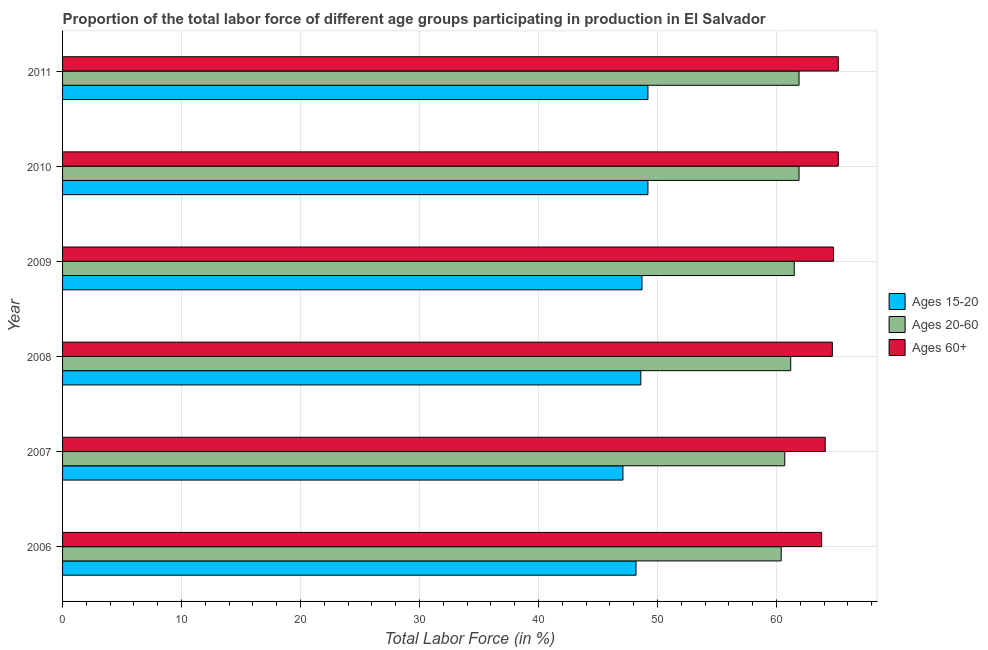How many different coloured bars are there?
Give a very brief answer. 3. How many bars are there on the 6th tick from the top?
Provide a short and direct response. 3. How many bars are there on the 5th tick from the bottom?
Your answer should be very brief. 3. What is the label of the 6th group of bars from the top?
Provide a succinct answer. 2006. What is the percentage of labor force within the age group 20-60 in 2011?
Your response must be concise. 61.9. Across all years, what is the maximum percentage of labor force above age 60?
Keep it short and to the point. 65.2. Across all years, what is the minimum percentage of labor force within the age group 15-20?
Offer a terse response. 47.1. What is the total percentage of labor force within the age group 20-60 in the graph?
Give a very brief answer. 367.6. What is the difference between the percentage of labor force within the age group 15-20 in 2009 and that in 2011?
Make the answer very short. -0.5. What is the difference between the percentage of labor force above age 60 in 2009 and the percentage of labor force within the age group 20-60 in 2011?
Provide a succinct answer. 2.9. What is the average percentage of labor force within the age group 20-60 per year?
Offer a terse response. 61.27. In the year 2009, what is the difference between the percentage of labor force within the age group 20-60 and percentage of labor force within the age group 15-20?
Make the answer very short. 12.8. Is the percentage of labor force within the age group 15-20 in 2007 less than that in 2008?
Your answer should be very brief. Yes. Is the difference between the percentage of labor force within the age group 15-20 in 2006 and 2007 greater than the difference between the percentage of labor force within the age group 20-60 in 2006 and 2007?
Provide a succinct answer. Yes. What is the difference between the highest and the second highest percentage of labor force within the age group 15-20?
Your response must be concise. 0. What is the difference between the highest and the lowest percentage of labor force above age 60?
Your answer should be very brief. 1.4. In how many years, is the percentage of labor force within the age group 15-20 greater than the average percentage of labor force within the age group 15-20 taken over all years?
Make the answer very short. 4. Is the sum of the percentage of labor force within the age group 20-60 in 2006 and 2010 greater than the maximum percentage of labor force within the age group 15-20 across all years?
Ensure brevity in your answer.  Yes. What does the 2nd bar from the top in 2008 represents?
Your answer should be compact. Ages 20-60. What does the 2nd bar from the bottom in 2008 represents?
Keep it short and to the point. Ages 20-60. Is it the case that in every year, the sum of the percentage of labor force within the age group 15-20 and percentage of labor force within the age group 20-60 is greater than the percentage of labor force above age 60?
Your answer should be very brief. Yes. How many bars are there?
Provide a short and direct response. 18. Are all the bars in the graph horizontal?
Provide a short and direct response. Yes. How many years are there in the graph?
Provide a succinct answer. 6. What is the difference between two consecutive major ticks on the X-axis?
Provide a succinct answer. 10. Are the values on the major ticks of X-axis written in scientific E-notation?
Provide a succinct answer. No. Does the graph contain any zero values?
Your answer should be very brief. No. Does the graph contain grids?
Your answer should be very brief. Yes. Where does the legend appear in the graph?
Offer a very short reply. Center right. What is the title of the graph?
Your answer should be compact. Proportion of the total labor force of different age groups participating in production in El Salvador. Does "Primary" appear as one of the legend labels in the graph?
Give a very brief answer. No. What is the label or title of the Y-axis?
Give a very brief answer. Year. What is the Total Labor Force (in %) in Ages 15-20 in 2006?
Offer a very short reply. 48.2. What is the Total Labor Force (in %) of Ages 20-60 in 2006?
Your response must be concise. 60.4. What is the Total Labor Force (in %) of Ages 60+ in 2006?
Your response must be concise. 63.8. What is the Total Labor Force (in %) of Ages 15-20 in 2007?
Your answer should be compact. 47.1. What is the Total Labor Force (in %) of Ages 20-60 in 2007?
Your answer should be very brief. 60.7. What is the Total Labor Force (in %) in Ages 60+ in 2007?
Offer a very short reply. 64.1. What is the Total Labor Force (in %) of Ages 15-20 in 2008?
Your response must be concise. 48.6. What is the Total Labor Force (in %) of Ages 20-60 in 2008?
Your answer should be very brief. 61.2. What is the Total Labor Force (in %) of Ages 60+ in 2008?
Make the answer very short. 64.7. What is the Total Labor Force (in %) of Ages 15-20 in 2009?
Your response must be concise. 48.7. What is the Total Labor Force (in %) of Ages 20-60 in 2009?
Offer a very short reply. 61.5. What is the Total Labor Force (in %) of Ages 60+ in 2009?
Provide a short and direct response. 64.8. What is the Total Labor Force (in %) of Ages 15-20 in 2010?
Make the answer very short. 49.2. What is the Total Labor Force (in %) in Ages 20-60 in 2010?
Keep it short and to the point. 61.9. What is the Total Labor Force (in %) in Ages 60+ in 2010?
Make the answer very short. 65.2. What is the Total Labor Force (in %) in Ages 15-20 in 2011?
Keep it short and to the point. 49.2. What is the Total Labor Force (in %) in Ages 20-60 in 2011?
Keep it short and to the point. 61.9. What is the Total Labor Force (in %) in Ages 60+ in 2011?
Offer a very short reply. 65.2. Across all years, what is the maximum Total Labor Force (in %) of Ages 15-20?
Your answer should be very brief. 49.2. Across all years, what is the maximum Total Labor Force (in %) of Ages 20-60?
Make the answer very short. 61.9. Across all years, what is the maximum Total Labor Force (in %) in Ages 60+?
Offer a very short reply. 65.2. Across all years, what is the minimum Total Labor Force (in %) of Ages 15-20?
Provide a short and direct response. 47.1. Across all years, what is the minimum Total Labor Force (in %) of Ages 20-60?
Your answer should be very brief. 60.4. Across all years, what is the minimum Total Labor Force (in %) in Ages 60+?
Offer a terse response. 63.8. What is the total Total Labor Force (in %) of Ages 15-20 in the graph?
Give a very brief answer. 291. What is the total Total Labor Force (in %) of Ages 20-60 in the graph?
Provide a succinct answer. 367.6. What is the total Total Labor Force (in %) of Ages 60+ in the graph?
Give a very brief answer. 387.8. What is the difference between the Total Labor Force (in %) of Ages 15-20 in 2006 and that in 2007?
Your response must be concise. 1.1. What is the difference between the Total Labor Force (in %) of Ages 20-60 in 2006 and that in 2008?
Provide a short and direct response. -0.8. What is the difference between the Total Labor Force (in %) in Ages 15-20 in 2006 and that in 2009?
Provide a succinct answer. -0.5. What is the difference between the Total Labor Force (in %) of Ages 15-20 in 2006 and that in 2011?
Give a very brief answer. -1. What is the difference between the Total Labor Force (in %) in Ages 20-60 in 2007 and that in 2008?
Your response must be concise. -0.5. What is the difference between the Total Labor Force (in %) of Ages 60+ in 2007 and that in 2008?
Keep it short and to the point. -0.6. What is the difference between the Total Labor Force (in %) in Ages 60+ in 2007 and that in 2009?
Your answer should be compact. -0.7. What is the difference between the Total Labor Force (in %) in Ages 20-60 in 2007 and that in 2011?
Keep it short and to the point. -1.2. What is the difference between the Total Labor Force (in %) of Ages 60+ in 2007 and that in 2011?
Your answer should be very brief. -1.1. What is the difference between the Total Labor Force (in %) in Ages 15-20 in 2008 and that in 2010?
Offer a terse response. -0.6. What is the difference between the Total Labor Force (in %) in Ages 15-20 in 2008 and that in 2011?
Offer a terse response. -0.6. What is the difference between the Total Labor Force (in %) in Ages 60+ in 2008 and that in 2011?
Offer a terse response. -0.5. What is the difference between the Total Labor Force (in %) in Ages 20-60 in 2009 and that in 2010?
Your answer should be compact. -0.4. What is the difference between the Total Labor Force (in %) of Ages 60+ in 2009 and that in 2010?
Give a very brief answer. -0.4. What is the difference between the Total Labor Force (in %) of Ages 60+ in 2009 and that in 2011?
Provide a short and direct response. -0.4. What is the difference between the Total Labor Force (in %) of Ages 15-20 in 2010 and that in 2011?
Keep it short and to the point. 0. What is the difference between the Total Labor Force (in %) of Ages 60+ in 2010 and that in 2011?
Ensure brevity in your answer.  0. What is the difference between the Total Labor Force (in %) in Ages 15-20 in 2006 and the Total Labor Force (in %) in Ages 20-60 in 2007?
Keep it short and to the point. -12.5. What is the difference between the Total Labor Force (in %) in Ages 15-20 in 2006 and the Total Labor Force (in %) in Ages 60+ in 2007?
Keep it short and to the point. -15.9. What is the difference between the Total Labor Force (in %) in Ages 15-20 in 2006 and the Total Labor Force (in %) in Ages 20-60 in 2008?
Offer a terse response. -13. What is the difference between the Total Labor Force (in %) of Ages 15-20 in 2006 and the Total Labor Force (in %) of Ages 60+ in 2008?
Offer a very short reply. -16.5. What is the difference between the Total Labor Force (in %) of Ages 15-20 in 2006 and the Total Labor Force (in %) of Ages 60+ in 2009?
Your answer should be very brief. -16.6. What is the difference between the Total Labor Force (in %) of Ages 20-60 in 2006 and the Total Labor Force (in %) of Ages 60+ in 2009?
Offer a terse response. -4.4. What is the difference between the Total Labor Force (in %) in Ages 15-20 in 2006 and the Total Labor Force (in %) in Ages 20-60 in 2010?
Ensure brevity in your answer.  -13.7. What is the difference between the Total Labor Force (in %) of Ages 15-20 in 2006 and the Total Labor Force (in %) of Ages 60+ in 2010?
Make the answer very short. -17. What is the difference between the Total Labor Force (in %) in Ages 15-20 in 2006 and the Total Labor Force (in %) in Ages 20-60 in 2011?
Your response must be concise. -13.7. What is the difference between the Total Labor Force (in %) of Ages 20-60 in 2006 and the Total Labor Force (in %) of Ages 60+ in 2011?
Your answer should be compact. -4.8. What is the difference between the Total Labor Force (in %) of Ages 15-20 in 2007 and the Total Labor Force (in %) of Ages 20-60 in 2008?
Offer a very short reply. -14.1. What is the difference between the Total Labor Force (in %) of Ages 15-20 in 2007 and the Total Labor Force (in %) of Ages 60+ in 2008?
Your answer should be very brief. -17.6. What is the difference between the Total Labor Force (in %) in Ages 15-20 in 2007 and the Total Labor Force (in %) in Ages 20-60 in 2009?
Your answer should be very brief. -14.4. What is the difference between the Total Labor Force (in %) in Ages 15-20 in 2007 and the Total Labor Force (in %) in Ages 60+ in 2009?
Make the answer very short. -17.7. What is the difference between the Total Labor Force (in %) of Ages 15-20 in 2007 and the Total Labor Force (in %) of Ages 20-60 in 2010?
Give a very brief answer. -14.8. What is the difference between the Total Labor Force (in %) in Ages 15-20 in 2007 and the Total Labor Force (in %) in Ages 60+ in 2010?
Keep it short and to the point. -18.1. What is the difference between the Total Labor Force (in %) in Ages 20-60 in 2007 and the Total Labor Force (in %) in Ages 60+ in 2010?
Provide a succinct answer. -4.5. What is the difference between the Total Labor Force (in %) of Ages 15-20 in 2007 and the Total Labor Force (in %) of Ages 20-60 in 2011?
Give a very brief answer. -14.8. What is the difference between the Total Labor Force (in %) in Ages 15-20 in 2007 and the Total Labor Force (in %) in Ages 60+ in 2011?
Provide a short and direct response. -18.1. What is the difference between the Total Labor Force (in %) in Ages 20-60 in 2007 and the Total Labor Force (in %) in Ages 60+ in 2011?
Make the answer very short. -4.5. What is the difference between the Total Labor Force (in %) of Ages 15-20 in 2008 and the Total Labor Force (in %) of Ages 60+ in 2009?
Provide a succinct answer. -16.2. What is the difference between the Total Labor Force (in %) of Ages 20-60 in 2008 and the Total Labor Force (in %) of Ages 60+ in 2009?
Offer a very short reply. -3.6. What is the difference between the Total Labor Force (in %) of Ages 15-20 in 2008 and the Total Labor Force (in %) of Ages 60+ in 2010?
Your answer should be very brief. -16.6. What is the difference between the Total Labor Force (in %) in Ages 20-60 in 2008 and the Total Labor Force (in %) in Ages 60+ in 2010?
Keep it short and to the point. -4. What is the difference between the Total Labor Force (in %) of Ages 15-20 in 2008 and the Total Labor Force (in %) of Ages 60+ in 2011?
Provide a short and direct response. -16.6. What is the difference between the Total Labor Force (in %) of Ages 15-20 in 2009 and the Total Labor Force (in %) of Ages 20-60 in 2010?
Your answer should be very brief. -13.2. What is the difference between the Total Labor Force (in %) in Ages 15-20 in 2009 and the Total Labor Force (in %) in Ages 60+ in 2010?
Make the answer very short. -16.5. What is the difference between the Total Labor Force (in %) in Ages 15-20 in 2009 and the Total Labor Force (in %) in Ages 20-60 in 2011?
Keep it short and to the point. -13.2. What is the difference between the Total Labor Force (in %) of Ages 15-20 in 2009 and the Total Labor Force (in %) of Ages 60+ in 2011?
Offer a terse response. -16.5. What is the difference between the Total Labor Force (in %) in Ages 20-60 in 2009 and the Total Labor Force (in %) in Ages 60+ in 2011?
Provide a short and direct response. -3.7. What is the difference between the Total Labor Force (in %) of Ages 20-60 in 2010 and the Total Labor Force (in %) of Ages 60+ in 2011?
Give a very brief answer. -3.3. What is the average Total Labor Force (in %) in Ages 15-20 per year?
Offer a very short reply. 48.5. What is the average Total Labor Force (in %) in Ages 20-60 per year?
Your answer should be compact. 61.27. What is the average Total Labor Force (in %) in Ages 60+ per year?
Ensure brevity in your answer.  64.63. In the year 2006, what is the difference between the Total Labor Force (in %) in Ages 15-20 and Total Labor Force (in %) in Ages 20-60?
Offer a very short reply. -12.2. In the year 2006, what is the difference between the Total Labor Force (in %) in Ages 15-20 and Total Labor Force (in %) in Ages 60+?
Give a very brief answer. -15.6. In the year 2007, what is the difference between the Total Labor Force (in %) in Ages 15-20 and Total Labor Force (in %) in Ages 20-60?
Provide a succinct answer. -13.6. In the year 2008, what is the difference between the Total Labor Force (in %) in Ages 15-20 and Total Labor Force (in %) in Ages 60+?
Make the answer very short. -16.1. In the year 2009, what is the difference between the Total Labor Force (in %) of Ages 15-20 and Total Labor Force (in %) of Ages 60+?
Provide a succinct answer. -16.1. In the year 2010, what is the difference between the Total Labor Force (in %) of Ages 15-20 and Total Labor Force (in %) of Ages 20-60?
Give a very brief answer. -12.7. In the year 2010, what is the difference between the Total Labor Force (in %) in Ages 15-20 and Total Labor Force (in %) in Ages 60+?
Give a very brief answer. -16. In the year 2011, what is the difference between the Total Labor Force (in %) in Ages 15-20 and Total Labor Force (in %) in Ages 60+?
Provide a succinct answer. -16. In the year 2011, what is the difference between the Total Labor Force (in %) of Ages 20-60 and Total Labor Force (in %) of Ages 60+?
Provide a short and direct response. -3.3. What is the ratio of the Total Labor Force (in %) of Ages 15-20 in 2006 to that in 2007?
Make the answer very short. 1.02. What is the ratio of the Total Labor Force (in %) in Ages 20-60 in 2006 to that in 2007?
Your answer should be very brief. 1. What is the ratio of the Total Labor Force (in %) of Ages 60+ in 2006 to that in 2007?
Ensure brevity in your answer.  1. What is the ratio of the Total Labor Force (in %) in Ages 15-20 in 2006 to that in 2008?
Your answer should be very brief. 0.99. What is the ratio of the Total Labor Force (in %) of Ages 20-60 in 2006 to that in 2008?
Make the answer very short. 0.99. What is the ratio of the Total Labor Force (in %) of Ages 60+ in 2006 to that in 2008?
Give a very brief answer. 0.99. What is the ratio of the Total Labor Force (in %) in Ages 15-20 in 2006 to that in 2009?
Your answer should be compact. 0.99. What is the ratio of the Total Labor Force (in %) in Ages 20-60 in 2006 to that in 2009?
Give a very brief answer. 0.98. What is the ratio of the Total Labor Force (in %) in Ages 60+ in 2006 to that in 2009?
Ensure brevity in your answer.  0.98. What is the ratio of the Total Labor Force (in %) in Ages 15-20 in 2006 to that in 2010?
Keep it short and to the point. 0.98. What is the ratio of the Total Labor Force (in %) of Ages 20-60 in 2006 to that in 2010?
Provide a succinct answer. 0.98. What is the ratio of the Total Labor Force (in %) in Ages 60+ in 2006 to that in 2010?
Provide a short and direct response. 0.98. What is the ratio of the Total Labor Force (in %) of Ages 15-20 in 2006 to that in 2011?
Offer a very short reply. 0.98. What is the ratio of the Total Labor Force (in %) in Ages 20-60 in 2006 to that in 2011?
Your response must be concise. 0.98. What is the ratio of the Total Labor Force (in %) in Ages 60+ in 2006 to that in 2011?
Make the answer very short. 0.98. What is the ratio of the Total Labor Force (in %) of Ages 15-20 in 2007 to that in 2008?
Offer a very short reply. 0.97. What is the ratio of the Total Labor Force (in %) of Ages 20-60 in 2007 to that in 2008?
Offer a terse response. 0.99. What is the ratio of the Total Labor Force (in %) in Ages 60+ in 2007 to that in 2008?
Ensure brevity in your answer.  0.99. What is the ratio of the Total Labor Force (in %) in Ages 15-20 in 2007 to that in 2009?
Keep it short and to the point. 0.97. What is the ratio of the Total Labor Force (in %) in Ages 15-20 in 2007 to that in 2010?
Give a very brief answer. 0.96. What is the ratio of the Total Labor Force (in %) of Ages 20-60 in 2007 to that in 2010?
Provide a short and direct response. 0.98. What is the ratio of the Total Labor Force (in %) in Ages 60+ in 2007 to that in 2010?
Your answer should be compact. 0.98. What is the ratio of the Total Labor Force (in %) of Ages 15-20 in 2007 to that in 2011?
Make the answer very short. 0.96. What is the ratio of the Total Labor Force (in %) of Ages 20-60 in 2007 to that in 2011?
Keep it short and to the point. 0.98. What is the ratio of the Total Labor Force (in %) in Ages 60+ in 2007 to that in 2011?
Your answer should be compact. 0.98. What is the ratio of the Total Labor Force (in %) in Ages 15-20 in 2008 to that in 2009?
Your response must be concise. 1. What is the ratio of the Total Labor Force (in %) of Ages 20-60 in 2008 to that in 2010?
Offer a terse response. 0.99. What is the ratio of the Total Labor Force (in %) of Ages 60+ in 2008 to that in 2010?
Make the answer very short. 0.99. What is the ratio of the Total Labor Force (in %) of Ages 15-20 in 2008 to that in 2011?
Provide a short and direct response. 0.99. What is the ratio of the Total Labor Force (in %) in Ages 20-60 in 2008 to that in 2011?
Provide a short and direct response. 0.99. What is the ratio of the Total Labor Force (in %) of Ages 20-60 in 2009 to that in 2010?
Offer a very short reply. 0.99. What is the ratio of the Total Labor Force (in %) of Ages 60+ in 2009 to that in 2010?
Offer a very short reply. 0.99. What is the ratio of the Total Labor Force (in %) in Ages 15-20 in 2009 to that in 2011?
Your answer should be very brief. 0.99. What is the ratio of the Total Labor Force (in %) in Ages 60+ in 2009 to that in 2011?
Offer a terse response. 0.99. What is the ratio of the Total Labor Force (in %) of Ages 20-60 in 2010 to that in 2011?
Your answer should be compact. 1. What is the ratio of the Total Labor Force (in %) of Ages 60+ in 2010 to that in 2011?
Your answer should be very brief. 1. What is the difference between the highest and the second highest Total Labor Force (in %) in Ages 20-60?
Your response must be concise. 0. What is the difference between the highest and the second highest Total Labor Force (in %) in Ages 60+?
Your response must be concise. 0. What is the difference between the highest and the lowest Total Labor Force (in %) in Ages 15-20?
Your answer should be very brief. 2.1. 